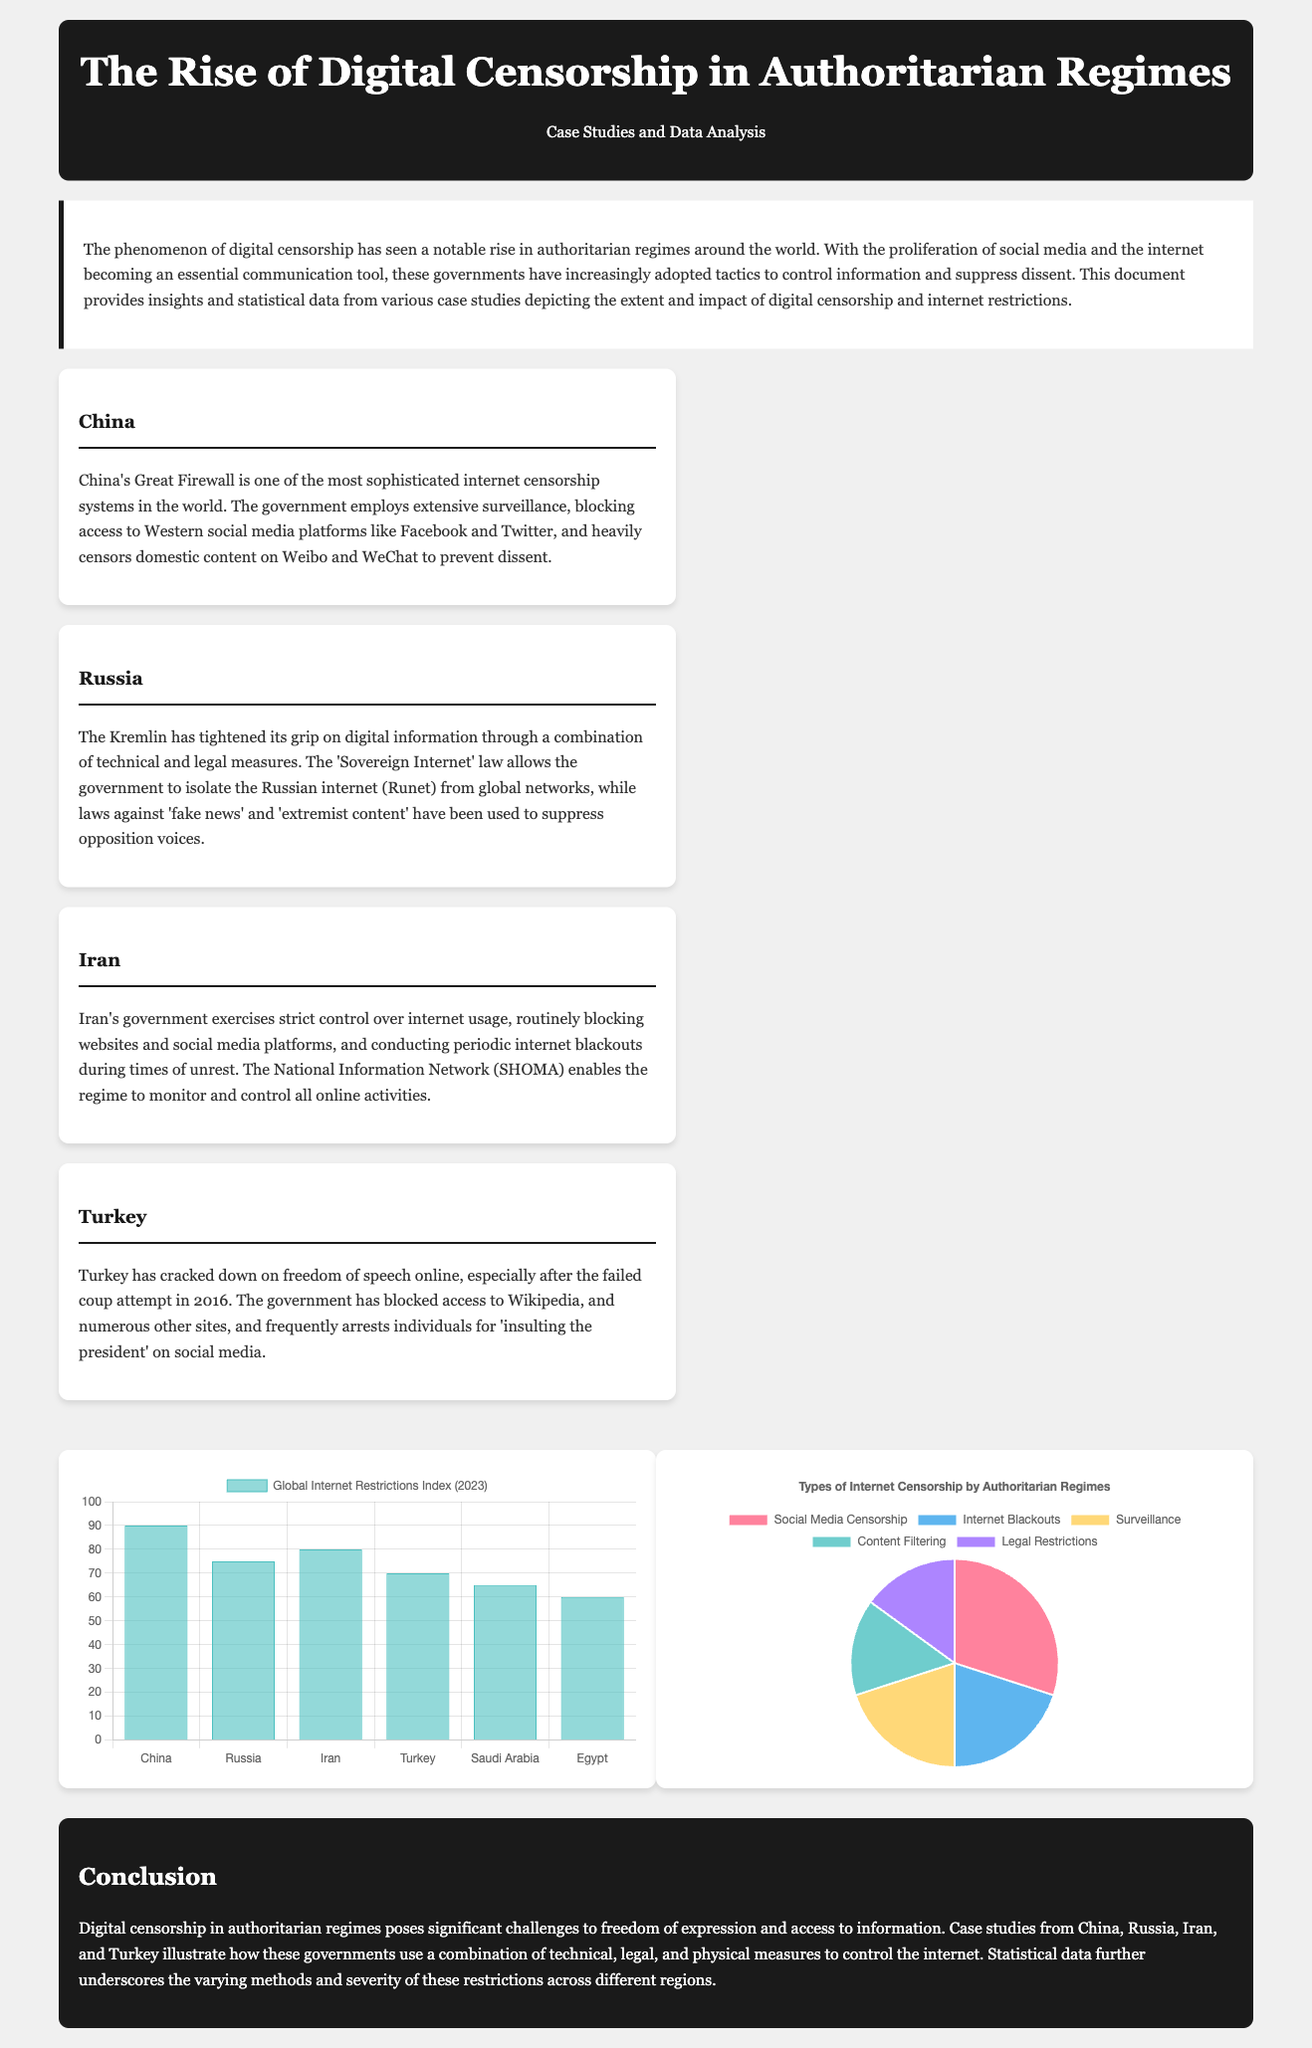What is the title of the document? The title of the document is stated at the top of the rendered webpage.
Answer: The Rise of Digital Censorship in Authoritarian Regimes What percentage of the Global Internet Restrictions Index does China have? The document provides a bar chart that indicates specific numbers for various countries.
Answer: 90 In which section do the case studies appear? The case studies are organized in a distinct section labeled specifically within the document.
Answer: Case Studies What is the largest type of internet censorship according to the pie chart? The pie chart illustrates different types of internet censorship with specific proportions along with labels indicating each type.
Answer: Social Media Censorship What legal measure is mentioned as being utilized by Russia? The document discusses various legal and technical measures employed in Russia within the context of digital censorship.
Answer: Sovereign Internet law Which country is mentioned first in the case studies section? The case studies are listed in the order they are presented, starting with the first country discussed.
Answer: China What is the main consequence of digital censorship highlighted in the conclusion? The conclusion summarizes the overall impact of digital censorship addressed throughout the document.
Answer: Challenges to freedom of expression 